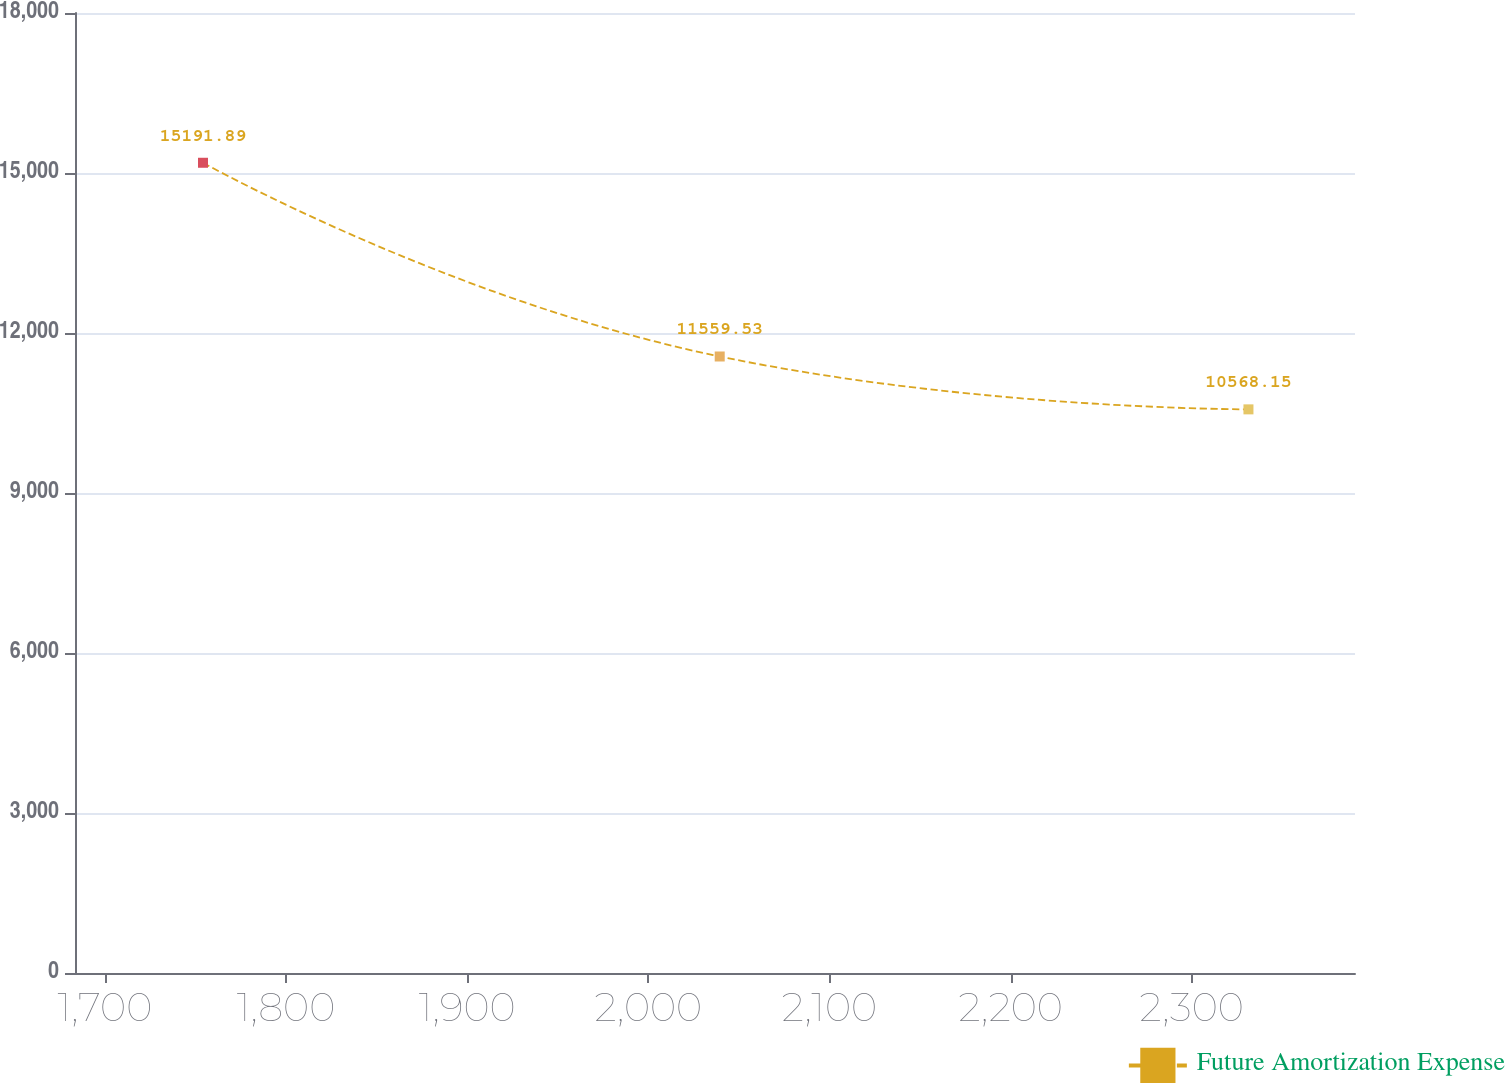<chart> <loc_0><loc_0><loc_500><loc_500><line_chart><ecel><fcel>Future Amortization Expense<nl><fcel>1754.16<fcel>15191.9<nl><fcel>2039.41<fcel>11559.5<nl><fcel>2331.3<fcel>10568.1<nl><fcel>2396.04<fcel>12456.7<nl><fcel>2460.78<fcel>6219.81<nl></chart> 